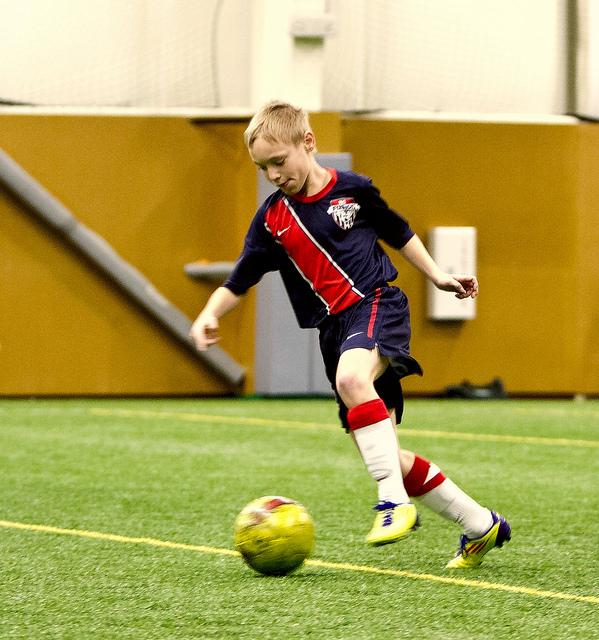What color hair does this boy have?
Be succinct. Blonde. What color are his socks?
Be succinct. White and red. What is the boy doing?
Keep it brief. Playing soccer. 